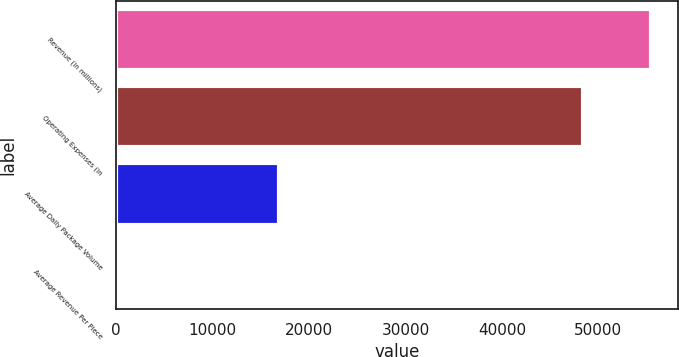<chart> <loc_0><loc_0><loc_500><loc_500><bar_chart><fcel>Revenue (in millions)<fcel>Operating Expenses (in<fcel>Average Daily Package Volume<fcel>Average Revenue Per Piece<nl><fcel>55438<fcel>48404<fcel>16938<fcel>10.76<nl></chart> 